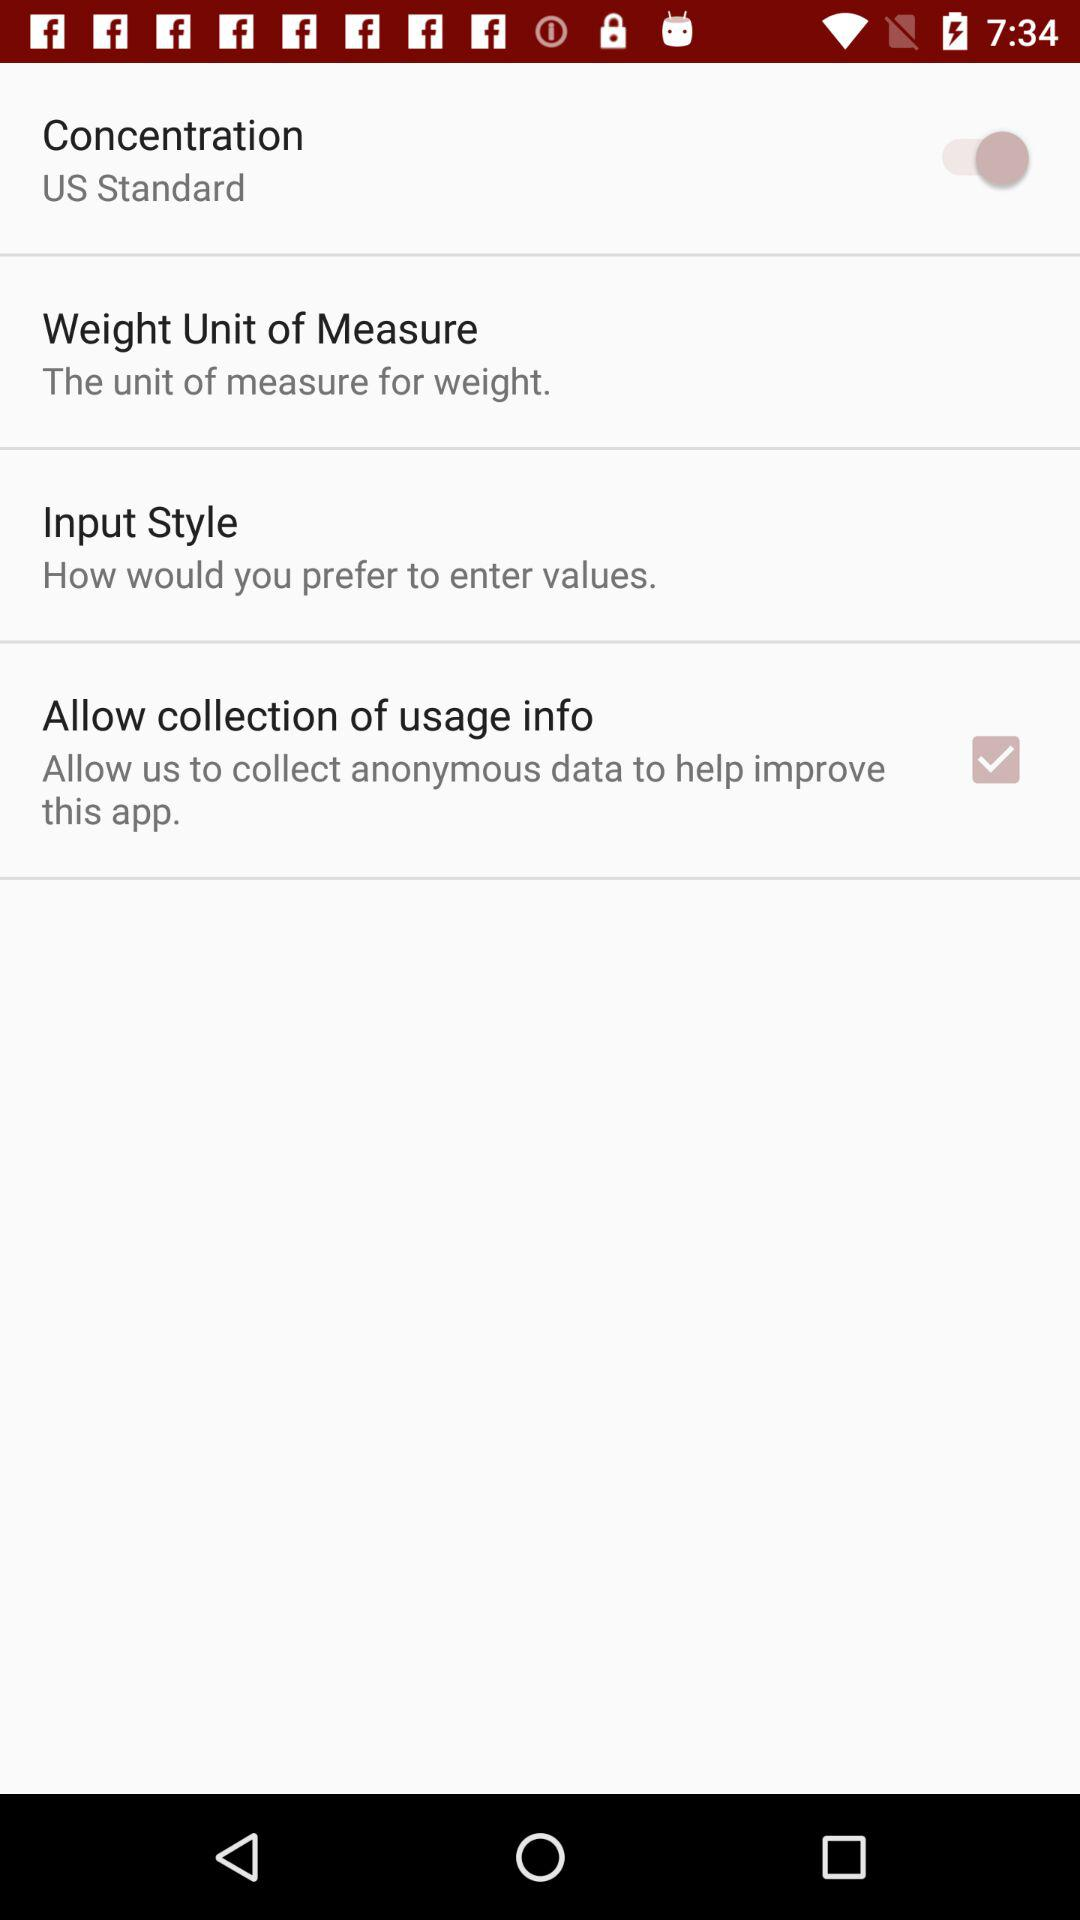What is the status of the "Allow collection of usage info"? The status is "on". 